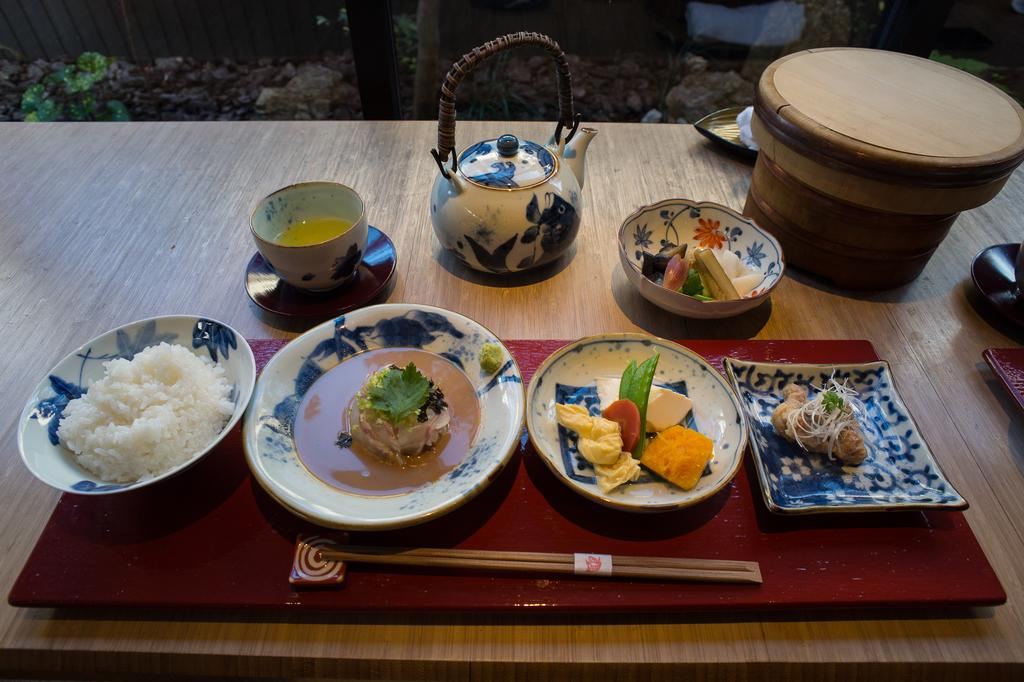What is present on the plates in the image? There is food in plates in the image. What utensil is visible in the image? Chopsticks are visible in the image. What type of container is present in the image? There is a cup in the image. What piece of furniture is present in the image? There is a table in the image. What type of tank is visible in the image? There is no tank present in the image. Is the prison visible in the image? There is no prison present in the image. 